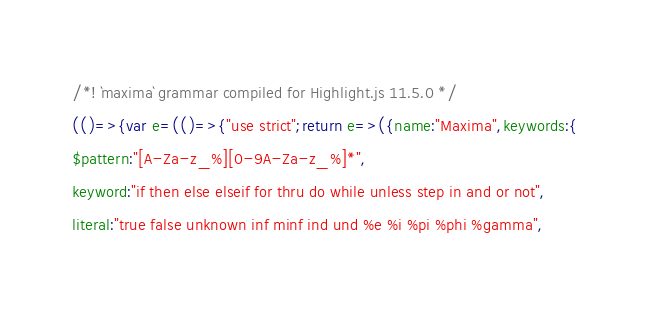Convert code to text. <code><loc_0><loc_0><loc_500><loc_500><_JavaScript_>/*! `maxima` grammar compiled for Highlight.js 11.5.0 */
(()=>{var e=(()=>{"use strict";return e=>({name:"Maxima",keywords:{
$pattern:"[A-Za-z_%][0-9A-Za-z_%]*",
keyword:"if then else elseif for thru do while unless step in and or not",
literal:"true false unknown inf minf ind und %e %i %pi %phi %gamma",</code> 